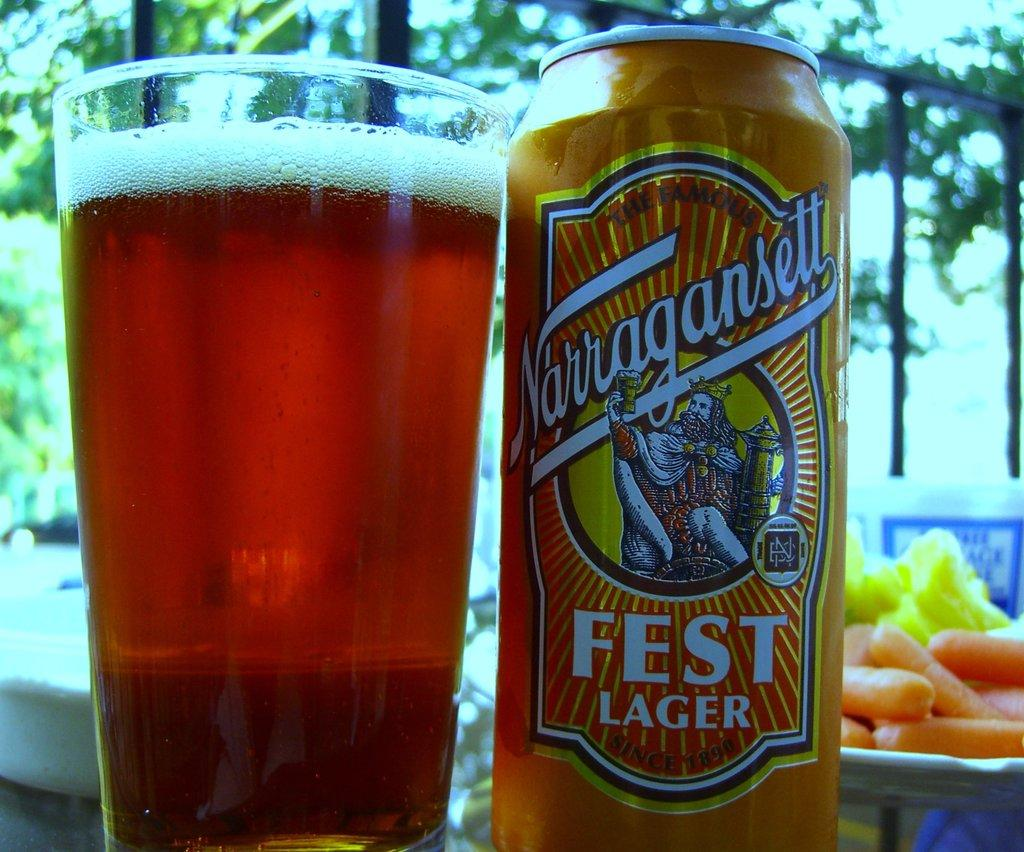<image>
Write a terse but informative summary of the picture. A full glass next to a can with Fest Lager written on it. 